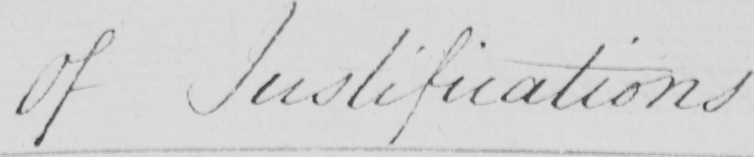Please transcribe the handwritten text in this image. Of Justifications . 